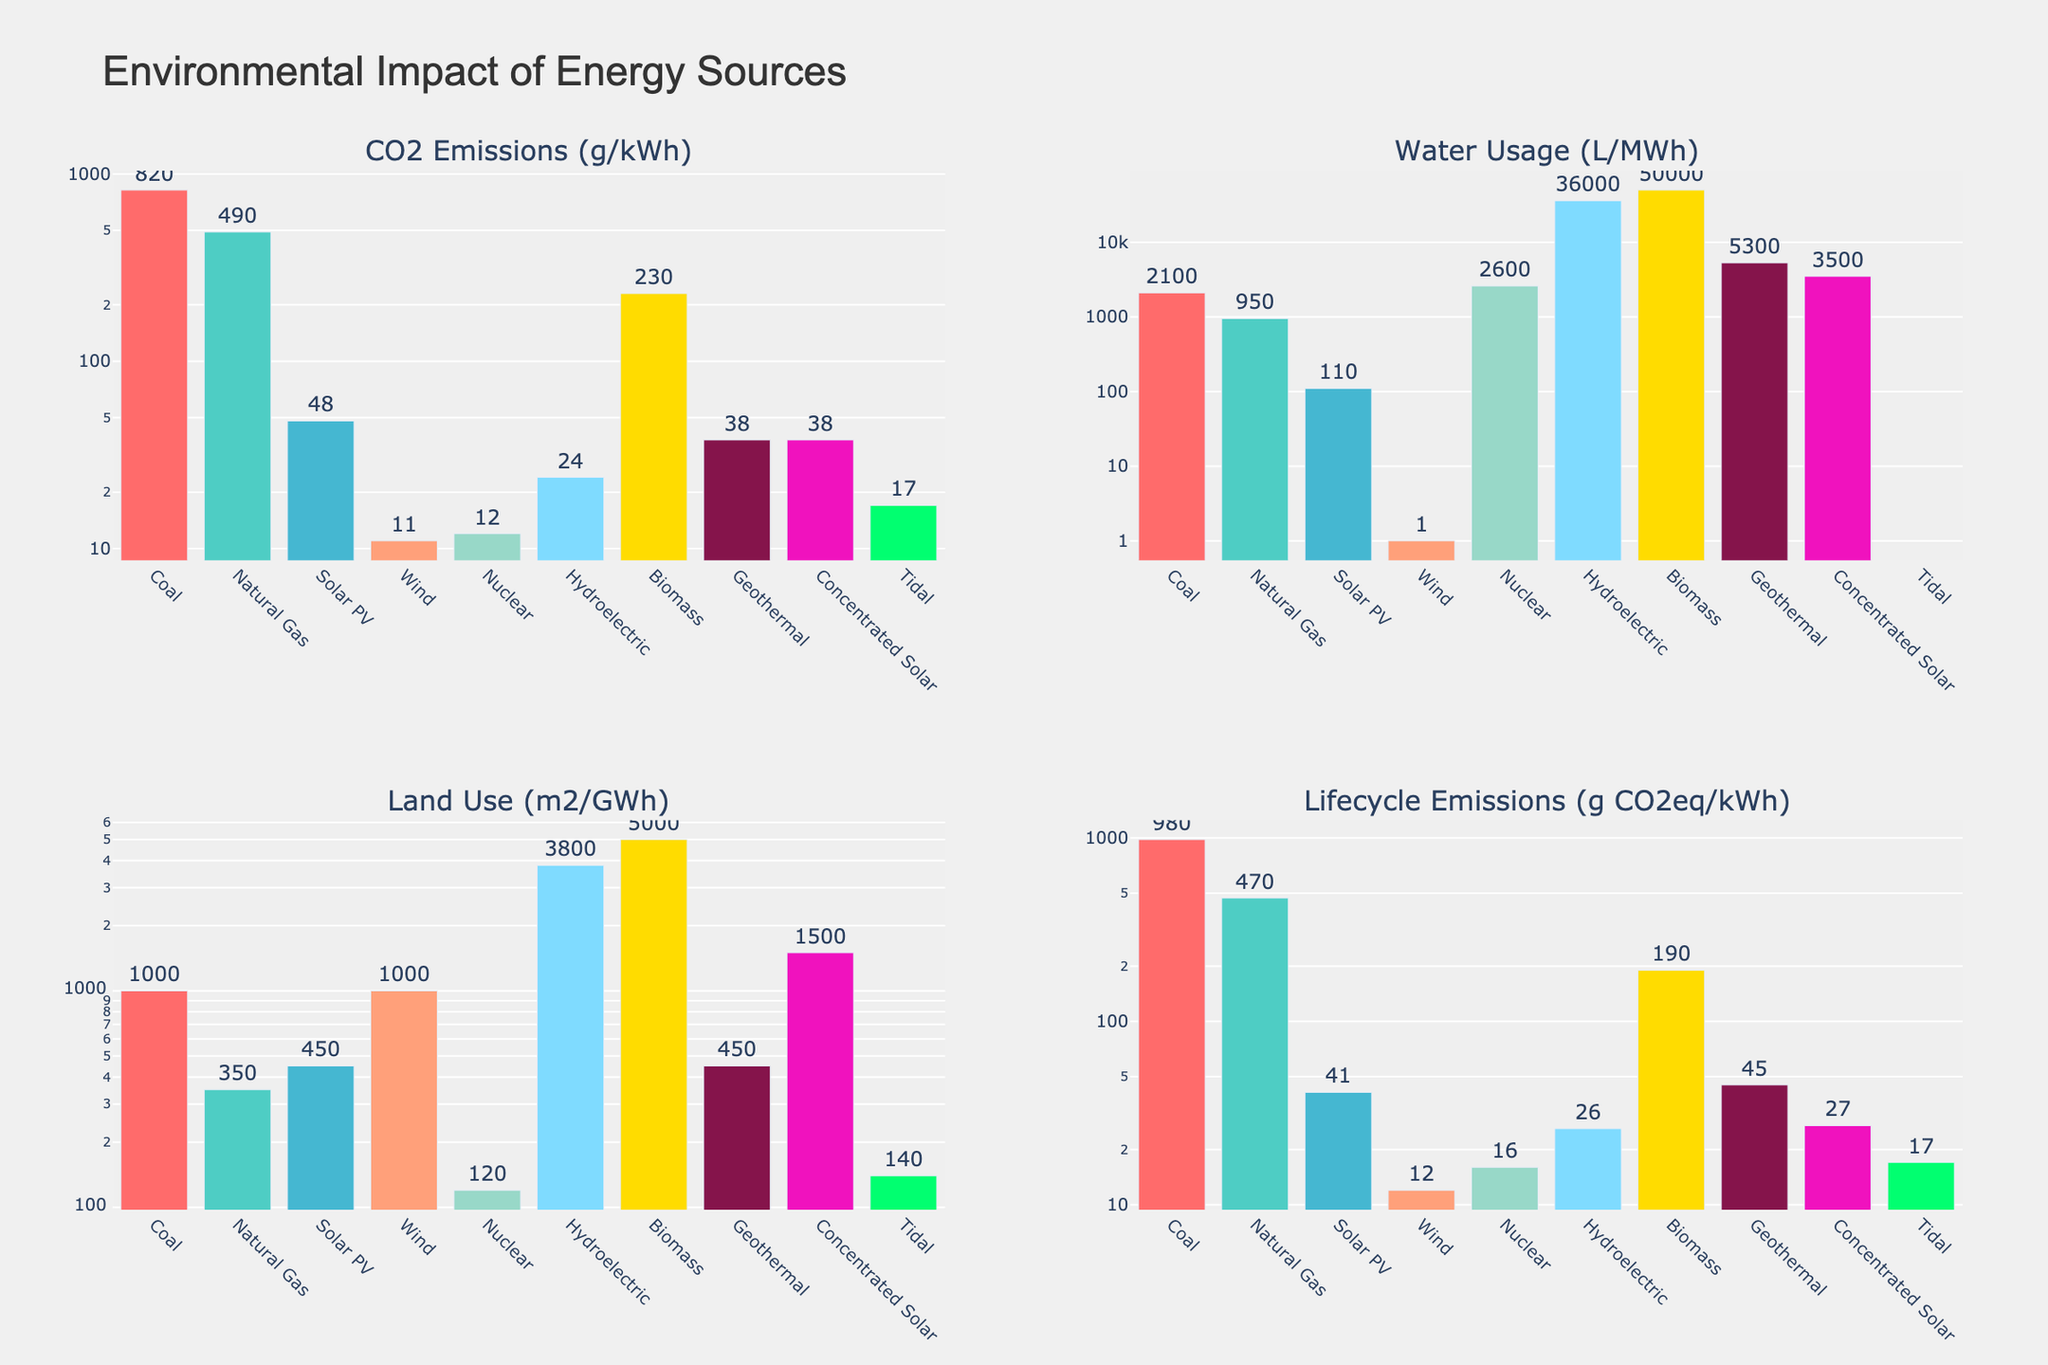What's the energy source with the highest CO2 emissions (g/kWh)? Coal has the highest bar in the 'CO2 Emissions (g/kWh)' subplot, indicating the greatest CO2 emissions value.
Answer: Coal Which energy source has the lowest water usage (L/MWh)? Wind shows the lowest bar in the 'Water Usage (L/MWh)' subplot, indicating the least water usage.
Answer: Wind How does the land use of solar PV compare to nuclear? In the 'Land Use (m2/GWh)' subplot, Solar PV has a higher bar than Nuclear, indicating greater land use for Solar PV compared to Nuclear.
Answer: Solar PV has greater land use than Nuclear Which energy source has the lowest lifecycle emissions (g CO2eq/kWh)? Wind has the smallest bar in the 'Lifecycle Emissions (g CO2eq/kWh)' subplot, indicating the lowest lifecycle emissions.
Answer: Wind What’s the average CO2 emissions (g/kWh) of the renewable energy sources (wind, solar PV, hydroelectric)? Wind has 11, Solar PV has 48, and Hydroelectric has 24 in the 'CO2 Emissions (g/kWh)' subplot. The average is calculated as (11 + 48 + 24)/3.
Answer: 27.67 Between biomass and geothermal, which uses more land per GWh? In the 'Land Use (m2/GWh)' subplot, Biomass has a taller bar compared to Geothermal, indicating more land usage.
Answer: Biomass Is tidal energy more efficient in terms of lifecycle emissions compared to geothermal? Tidal shows a shorter bar in the 'Lifecycle Emissions (g CO2eq/kWh)' subplot compared to Geothermal, indicating lower lifecycle emissions.
Answer: Yes, tidal is more efficient Comparing coal and natural gas, which has a greater difference between their CO2 emissions and lifecycle emissions? Coal has CO2 emissions of 820 g/kWh and lifecycle emissions of 980 g CO2eq/kWh (difference: 160). Natural Gas has CO2 emissions of 490 g/kWh and lifecycle emissions of 470 g CO2eq/kWh (difference: 20). 160 is greater than 20.
Answer: Coal What's the combined land use of hydroelectric and concentrated solar? In the 'Land Use (m2/GWh)' subplot, Hydroelectric has 3800 and Concentrated Solar has 1500. The combined land use is 3800 + 1500.
Answer: 5300 